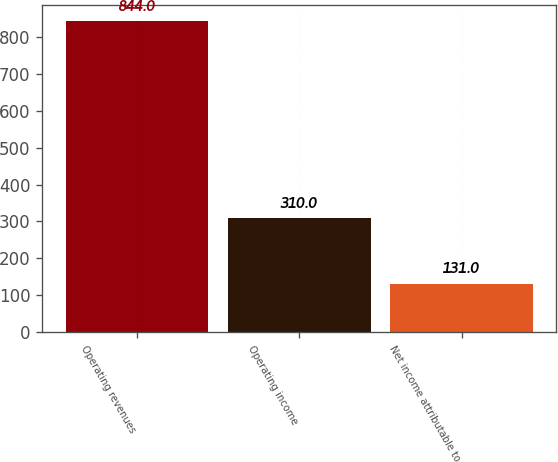Convert chart to OTSL. <chart><loc_0><loc_0><loc_500><loc_500><bar_chart><fcel>Operating revenues<fcel>Operating income<fcel>Net income attributable to<nl><fcel>844<fcel>310<fcel>131<nl></chart> 